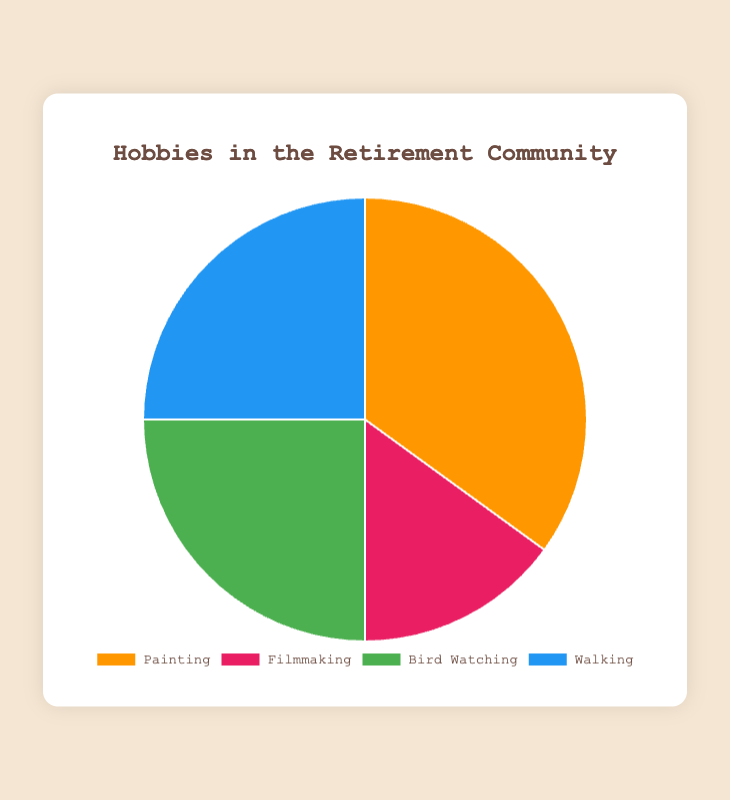What percentage of residents are interested in creative hobbies (Painting and Filmmaking)? To find the percentage of residents interested in creative hobbies, we need to add the percentages of Painting and Filmmaking. So, 35% (Painting) + 15% (Filmmaking) = 50%.
Answer: 50% Which hobby is the least popular among the residents? By looking at the percentages in the chart, Filmmaking has the smallest percentage at 15%.
Answer: Filmmaking How do the combined percentages of Bird Watching and Walking compare to Painting? First, we need to add the percentages of Bird Watching and Walking: 25% (Bird Watching) + 25% (Walking) = 50%. Painting is 35%. Since 50% (Bird Watching + Walking) is greater than 35% (Painting), the combined percentage of Bird Watching and Walking is higher.
Answer: Bird Watching and Walking combined are higher What is the difference in percentage between the most popular and least popular hobbies? The most popular hobby is Painting at 35%, and the least popular hobby is Filmmaking at 15%. The difference is 35% - 15% = 20%.
Answer: 20% Which two hobbies have equal interest among residents? By checking the percentages, Bird Watching and Walking both have 25%.
Answer: Bird Watching and Walking What is the total percentage of residents interested in Walking and Filmmaking? Adding the percentages of Walking (25%) and Filmmaking (15%) gives us 25% + 15% = 40%.
Answer: 40% What is the average percentage of residents interested in all four hobbies? To find the average, add all percentages and then divide by the number of hobbies. So, (35% + 15% + 25% + 25%) / 4 = 100% / 4 = 25%.
Answer: 25% Which hobby has the highest interest rate, and what is its color in the chart? The hobby with the highest interest rate is Painting at 35%. Its color in the chart is orange.
Answer: Painting, orange 